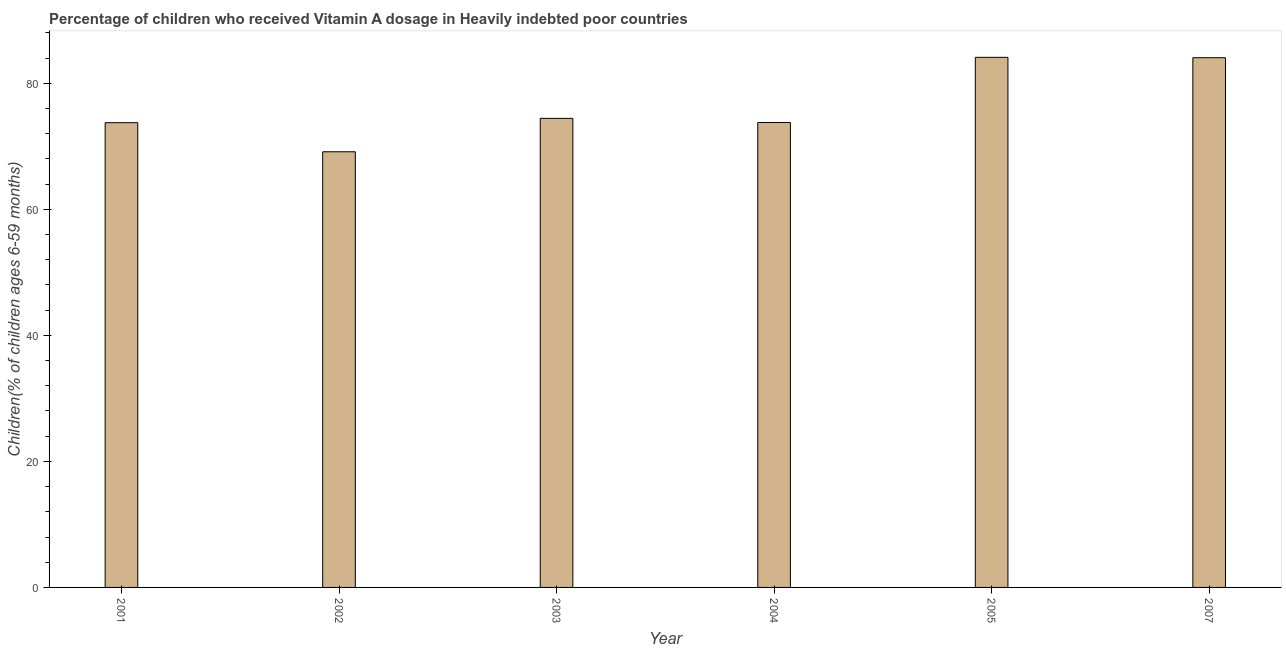Does the graph contain grids?
Give a very brief answer. No. What is the title of the graph?
Keep it short and to the point. Percentage of children who received Vitamin A dosage in Heavily indebted poor countries. What is the label or title of the Y-axis?
Give a very brief answer. Children(% of children ages 6-59 months). What is the vitamin a supplementation coverage rate in 2004?
Your answer should be very brief. 73.77. Across all years, what is the maximum vitamin a supplementation coverage rate?
Make the answer very short. 84.11. Across all years, what is the minimum vitamin a supplementation coverage rate?
Your response must be concise. 69.12. In which year was the vitamin a supplementation coverage rate maximum?
Give a very brief answer. 2005. What is the sum of the vitamin a supplementation coverage rate?
Keep it short and to the point. 459.22. What is the difference between the vitamin a supplementation coverage rate in 2004 and 2007?
Keep it short and to the point. -10.28. What is the average vitamin a supplementation coverage rate per year?
Give a very brief answer. 76.54. What is the median vitamin a supplementation coverage rate?
Offer a very short reply. 74.1. Do a majority of the years between 2007 and 2004 (inclusive) have vitamin a supplementation coverage rate greater than 72 %?
Your answer should be very brief. Yes. What is the ratio of the vitamin a supplementation coverage rate in 2001 to that in 2002?
Provide a short and direct response. 1.07. Is the sum of the vitamin a supplementation coverage rate in 2001 and 2007 greater than the maximum vitamin a supplementation coverage rate across all years?
Give a very brief answer. Yes. What is the difference between the highest and the lowest vitamin a supplementation coverage rate?
Provide a succinct answer. 14.99. How many bars are there?
Keep it short and to the point. 6. Are all the bars in the graph horizontal?
Your response must be concise. No. What is the difference between two consecutive major ticks on the Y-axis?
Provide a succinct answer. 20. Are the values on the major ticks of Y-axis written in scientific E-notation?
Your answer should be very brief. No. What is the Children(% of children ages 6-59 months) of 2001?
Your answer should be compact. 73.74. What is the Children(% of children ages 6-59 months) of 2002?
Keep it short and to the point. 69.12. What is the Children(% of children ages 6-59 months) in 2003?
Your response must be concise. 74.43. What is the Children(% of children ages 6-59 months) in 2004?
Make the answer very short. 73.77. What is the Children(% of children ages 6-59 months) of 2005?
Your answer should be compact. 84.11. What is the Children(% of children ages 6-59 months) in 2007?
Give a very brief answer. 84.05. What is the difference between the Children(% of children ages 6-59 months) in 2001 and 2002?
Give a very brief answer. 4.62. What is the difference between the Children(% of children ages 6-59 months) in 2001 and 2003?
Make the answer very short. -0.69. What is the difference between the Children(% of children ages 6-59 months) in 2001 and 2004?
Keep it short and to the point. -0.03. What is the difference between the Children(% of children ages 6-59 months) in 2001 and 2005?
Offer a very short reply. -10.37. What is the difference between the Children(% of children ages 6-59 months) in 2001 and 2007?
Your answer should be compact. -10.31. What is the difference between the Children(% of children ages 6-59 months) in 2002 and 2003?
Make the answer very short. -5.3. What is the difference between the Children(% of children ages 6-59 months) in 2002 and 2004?
Make the answer very short. -4.65. What is the difference between the Children(% of children ages 6-59 months) in 2002 and 2005?
Provide a succinct answer. -14.99. What is the difference between the Children(% of children ages 6-59 months) in 2002 and 2007?
Keep it short and to the point. -14.93. What is the difference between the Children(% of children ages 6-59 months) in 2003 and 2004?
Offer a terse response. 0.66. What is the difference between the Children(% of children ages 6-59 months) in 2003 and 2005?
Make the answer very short. -9.68. What is the difference between the Children(% of children ages 6-59 months) in 2003 and 2007?
Provide a short and direct response. -9.62. What is the difference between the Children(% of children ages 6-59 months) in 2004 and 2005?
Make the answer very short. -10.34. What is the difference between the Children(% of children ages 6-59 months) in 2004 and 2007?
Your response must be concise. -10.28. What is the difference between the Children(% of children ages 6-59 months) in 2005 and 2007?
Your answer should be compact. 0.06. What is the ratio of the Children(% of children ages 6-59 months) in 2001 to that in 2002?
Provide a short and direct response. 1.07. What is the ratio of the Children(% of children ages 6-59 months) in 2001 to that in 2003?
Offer a very short reply. 0.99. What is the ratio of the Children(% of children ages 6-59 months) in 2001 to that in 2004?
Offer a terse response. 1. What is the ratio of the Children(% of children ages 6-59 months) in 2001 to that in 2005?
Make the answer very short. 0.88. What is the ratio of the Children(% of children ages 6-59 months) in 2001 to that in 2007?
Give a very brief answer. 0.88. What is the ratio of the Children(% of children ages 6-59 months) in 2002 to that in 2003?
Ensure brevity in your answer.  0.93. What is the ratio of the Children(% of children ages 6-59 months) in 2002 to that in 2004?
Provide a short and direct response. 0.94. What is the ratio of the Children(% of children ages 6-59 months) in 2002 to that in 2005?
Offer a very short reply. 0.82. What is the ratio of the Children(% of children ages 6-59 months) in 2002 to that in 2007?
Your response must be concise. 0.82. What is the ratio of the Children(% of children ages 6-59 months) in 2003 to that in 2005?
Provide a short and direct response. 0.89. What is the ratio of the Children(% of children ages 6-59 months) in 2003 to that in 2007?
Offer a terse response. 0.89. What is the ratio of the Children(% of children ages 6-59 months) in 2004 to that in 2005?
Ensure brevity in your answer.  0.88. What is the ratio of the Children(% of children ages 6-59 months) in 2004 to that in 2007?
Offer a very short reply. 0.88. What is the ratio of the Children(% of children ages 6-59 months) in 2005 to that in 2007?
Your answer should be compact. 1. 